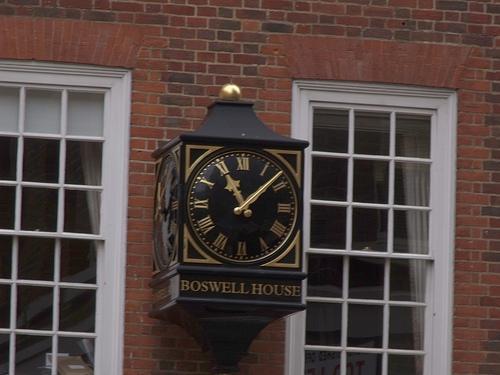How many windows are there?
Give a very brief answer. 2. How many hands are on the clock?
Give a very brief answer. 2. 